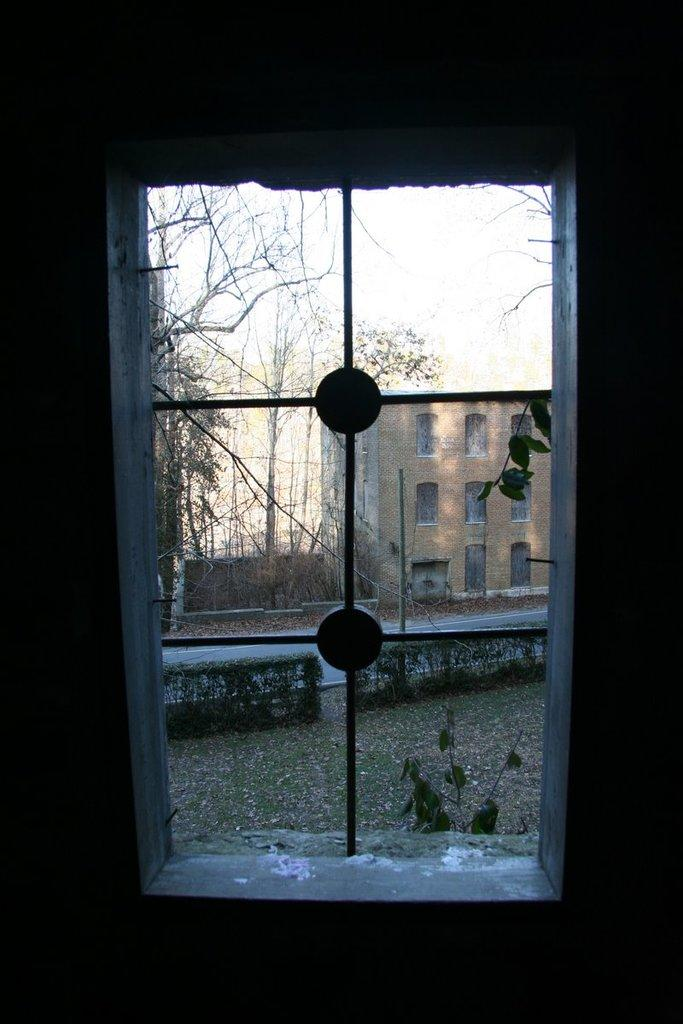What can be seen through the window in the image? The ground, plants, grass, trees, and the sky are visible through the window in the image. What is the primary surface visible in the image? The ground is the primary surface visible in the image. What type of vegetation is present in the image? Plants, grass, and trees are the types of vegetation present in the image. What structure can be seen in the image? There is a building in the image. What part of the natural environment is visible in the image? The sky is visible in the image. What type of sticks are being used in the battle depicted in the image? There is no battle or sticks present in the image; it features a window, ground, plants, grass, trees, and a building. 